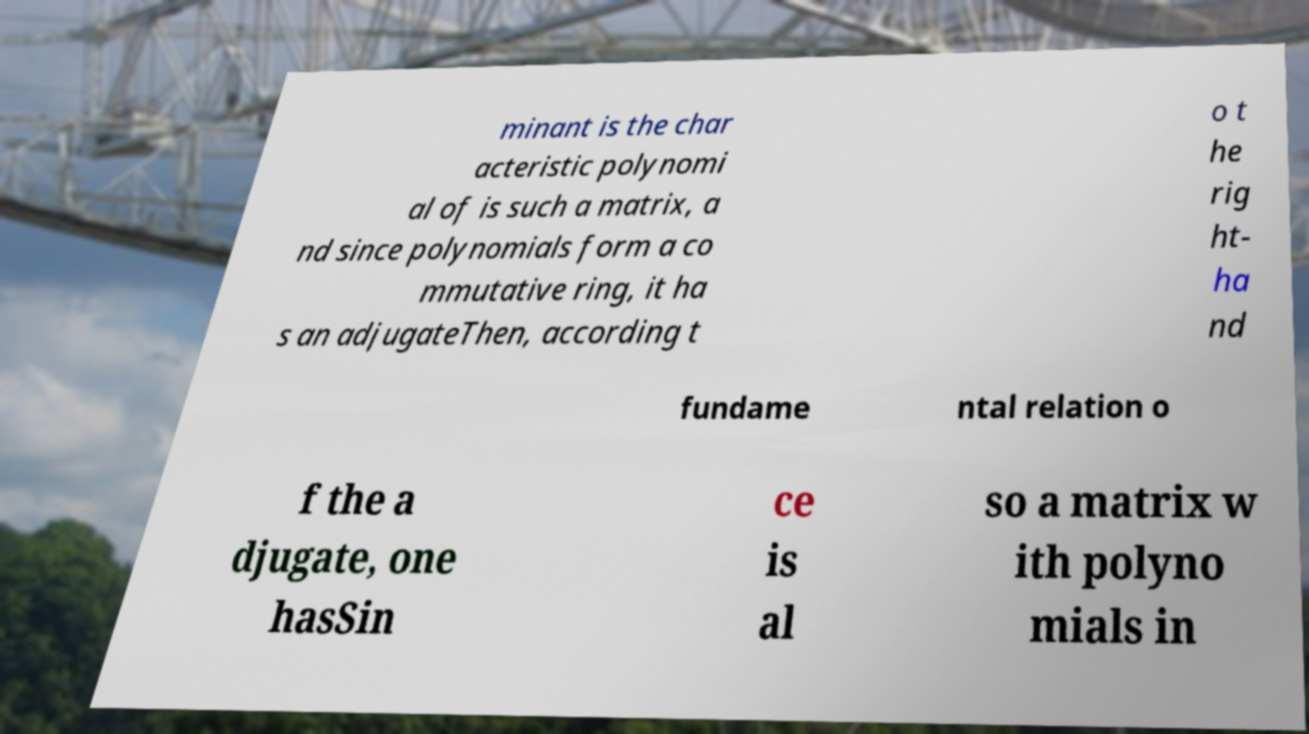Please identify and transcribe the text found in this image. minant is the char acteristic polynomi al of is such a matrix, a nd since polynomials form a co mmutative ring, it ha s an adjugateThen, according t o t he rig ht- ha nd fundame ntal relation o f the a djugate, one hasSin ce is al so a matrix w ith polyno mials in 